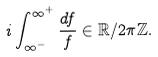<formula> <loc_0><loc_0><loc_500><loc_500>i \int _ { \infty ^ { - } } ^ { \infty ^ { + } } \frac { d f } { f } \in \mathbb { R } / 2 \pi \mathbb { Z } .</formula> 